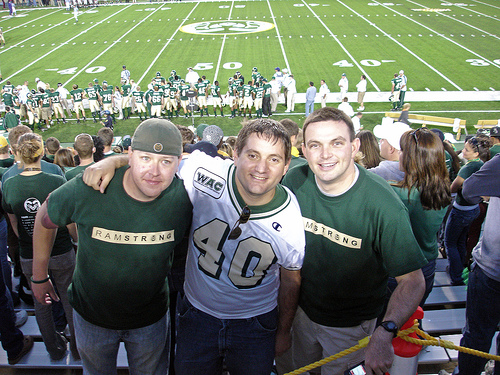<image>
Is there a play ground under the players? Yes. The play ground is positioned underneath the players, with the players above it in the vertical space. Where is the playground in relation to the man? Is it behind the man? No. The playground is not behind the man. From this viewpoint, the playground appears to be positioned elsewhere in the scene. 